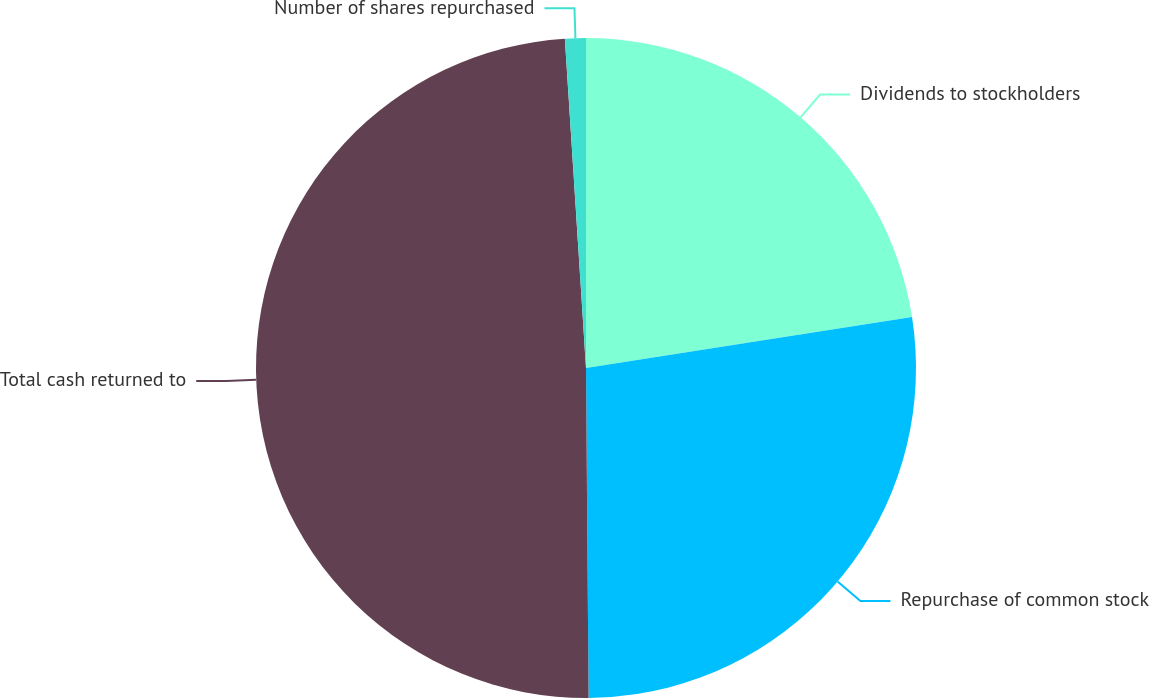<chart> <loc_0><loc_0><loc_500><loc_500><pie_chart><fcel>Dividends to stockholders<fcel>Repurchase of common stock<fcel>Total cash returned to<fcel>Number of shares repurchased<nl><fcel>22.53%<fcel>27.34%<fcel>49.1%<fcel>1.02%<nl></chart> 